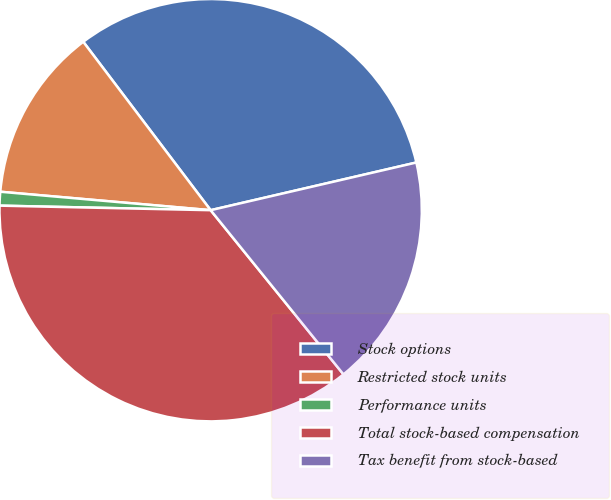Convert chart to OTSL. <chart><loc_0><loc_0><loc_500><loc_500><pie_chart><fcel>Stock options<fcel>Restricted stock units<fcel>Performance units<fcel>Total stock-based compensation<fcel>Tax benefit from stock-based<nl><fcel>31.68%<fcel>13.3%<fcel>1.05%<fcel>36.17%<fcel>17.8%<nl></chart> 